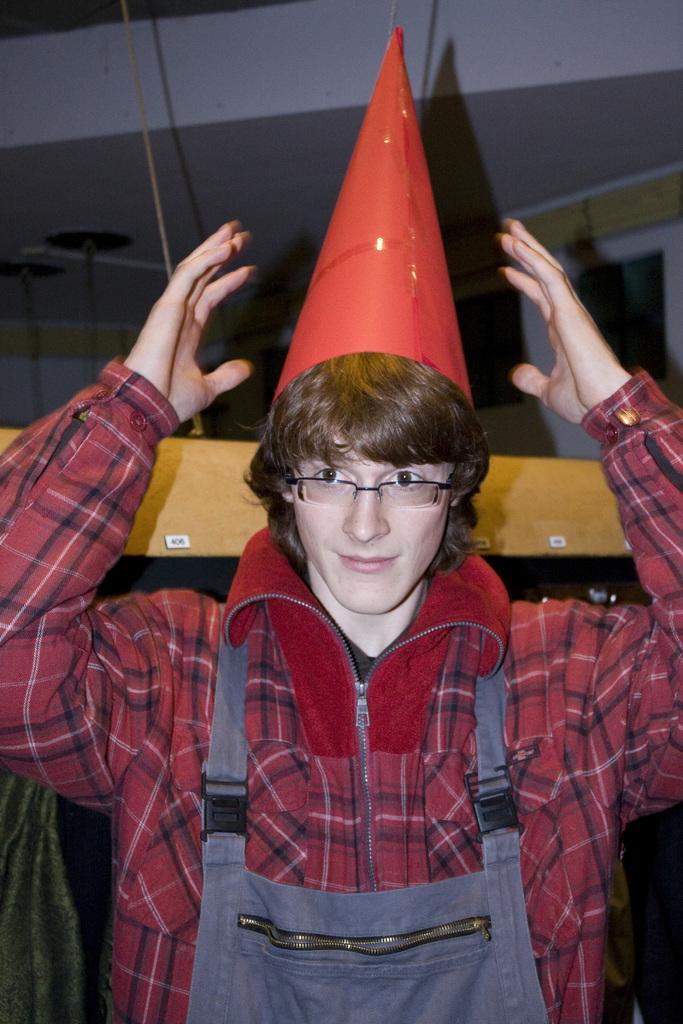Could you give a brief overview of what you see in this image? In this image we can see a person wearing a cap and behind him we can see the wall and wooden object. 